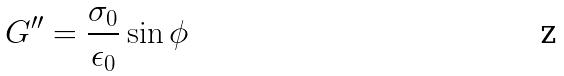<formula> <loc_0><loc_0><loc_500><loc_500>G ^ { \prime \prime } = \frac { \sigma _ { 0 } } { \epsilon _ { 0 } } \sin \phi</formula> 